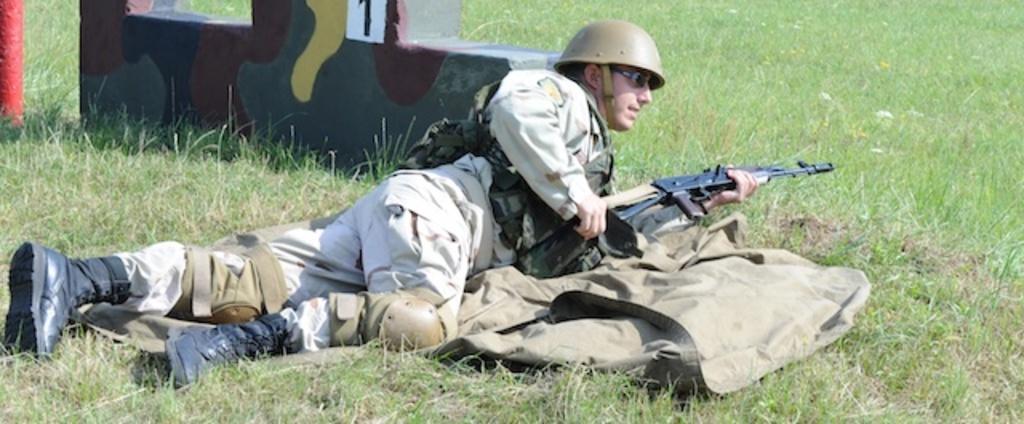Can you describe this image briefly? This image consists of a man lying on the ground. He is holding a gun and wearing a helmet. At the bottom, there is green grass on the ground. On the left, we can see a wall and a pole. 